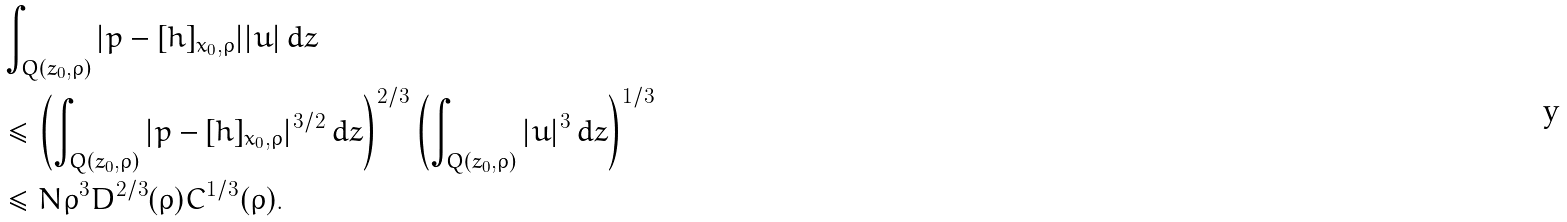Convert formula to latex. <formula><loc_0><loc_0><loc_500><loc_500>& \int _ { Q ( z _ { 0 } , \rho ) } | p - [ h ] _ { x _ { 0 } , \rho } | | u | \, d z \\ & \leq \left ( \int _ { Q ( z _ { 0 } , \rho ) } | p - [ h ] _ { x _ { 0 } , \rho } | ^ { 3 / 2 } \, d z \right ) ^ { 2 / 3 } \left ( \int _ { Q ( z _ { 0 } , \rho ) } | u | ^ { 3 } \, d z \right ) ^ { 1 / 3 } \\ & \leq N \rho ^ { 3 } D ^ { 2 / 3 } ( \rho ) C ^ { 1 / 3 } ( \rho ) .</formula> 